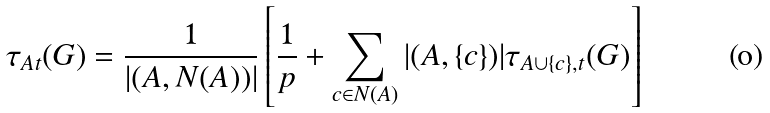<formula> <loc_0><loc_0><loc_500><loc_500>\tau _ { A t } ( G ) = \frac { 1 } { | ( A , N ( A ) ) | } \left [ \frac { 1 } { p } + \sum _ { c \in N ( A ) } | ( A , \{ c \} ) | \tau _ { A \cup \{ c \} , t } ( G ) \right ]</formula> 